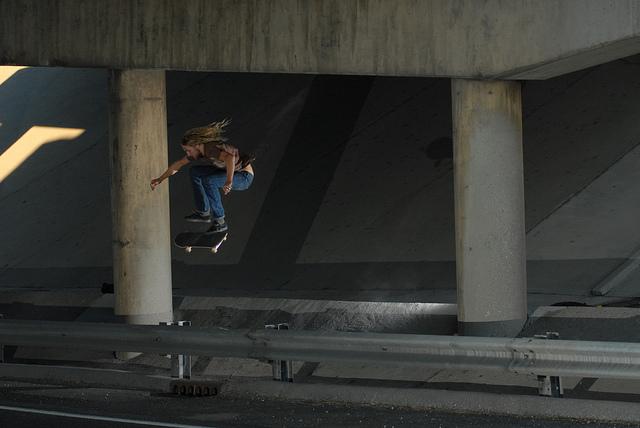Did this guy get air?
Quick response, please. Yes. Why is there so much shade?
Quick response, please. Under bridge. What is she holding?
Concise answer only. Nothing. What sport are these used for?
Quick response, please. Skateboarding. Does this person have short hair?
Be succinct. No. What are these?
Concise answer only. Skateboarder. 